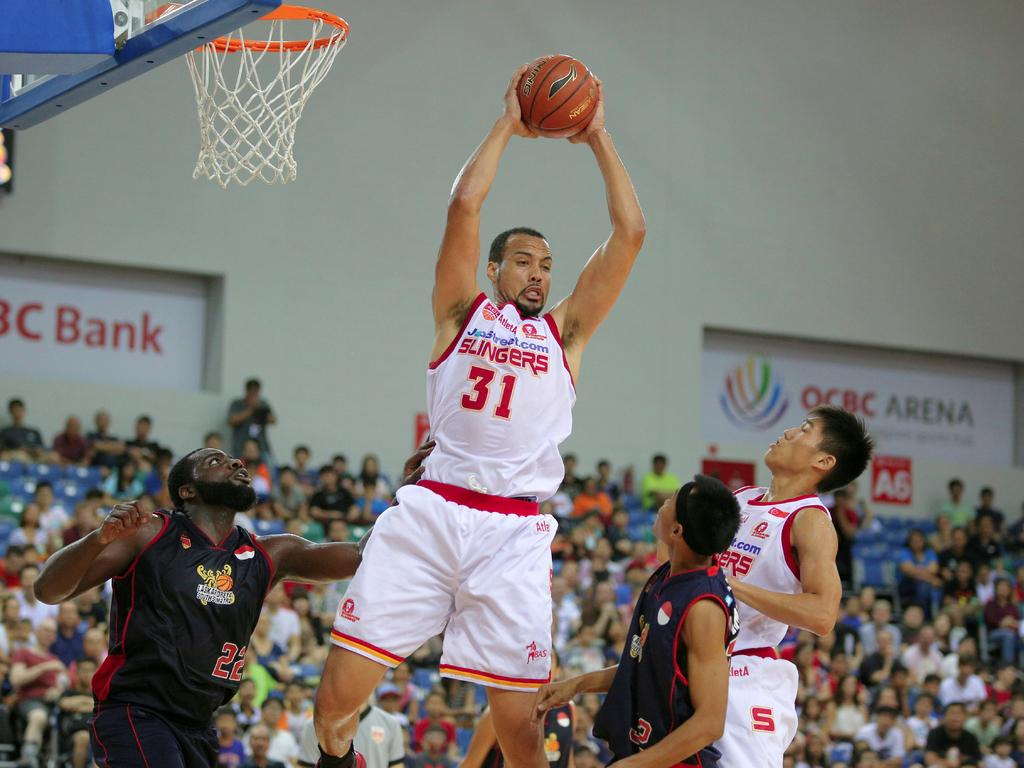<image>
Create a compact narrative representing the image presented. The player jumping with the ball is number 31 